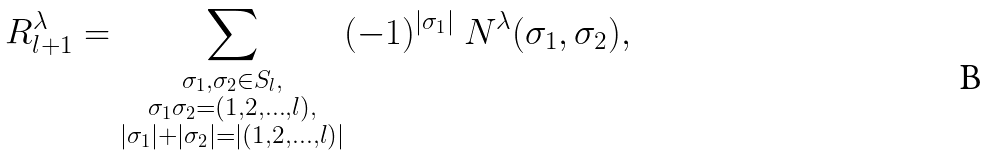Convert formula to latex. <formula><loc_0><loc_0><loc_500><loc_500>R _ { l + 1 } ^ { \lambda } = \sum _ { \substack { \sigma _ { 1 } , \sigma _ { 2 } \in S _ { l } , \\ \sigma _ { 1 } \sigma _ { 2 } = ( 1 , 2 , \dots , l ) , \\ | \sigma _ { 1 } | + | \sigma _ { 2 } | = | ( 1 , 2 , \dots , l ) | } } ( - 1 ) ^ { | \sigma _ { 1 } | } \ N ^ { \lambda } ( \sigma _ { 1 } , \sigma _ { 2 } ) ,</formula> 